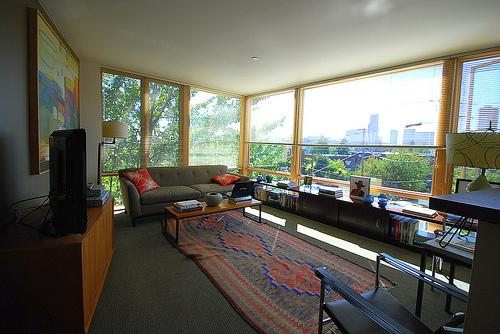How many windows are there in the room? There are multiple windows, but the exact number cannot be determined as they make up the wall of the room. What are the main colors you can perceive in the image? The main colors in the image are brown, red, green, and multi-colored patterns. Can you list some decorative elements in the living room? A large painting, a cowboy picture, a multi-colored rug, and red throw pillows are some decorative elements in the living room. What kind of view does the room offer, and how can it be seen? The room has amazing city views, seen through large windows that make up the wall. Describe what can be seen through the large windows in this room. A city skyline and a green tree can be seen through the large windows. What emotions or sentiments might this image evoke? The image might evoke feelings of comfort, relaxation, and modernity due to the living room setting and decorations. What are the items placed on the coffee table? There is a bowl, a laptop computer, and a small stack of books on the coffee table. Identify any electronic devices found in the living room and describe their state if applicable. There is a laptop computer, which is open, and a television set resting on a cabinet in the living room. What type of furniture can you find in the living room? There is a brown sofa, a coffee table, a television set, and a long bookshelf in the living room. Where is the lamp located in relation to the sofa and what is specific about its shade? The lamp is next to the sofa and has a patterned shade. 